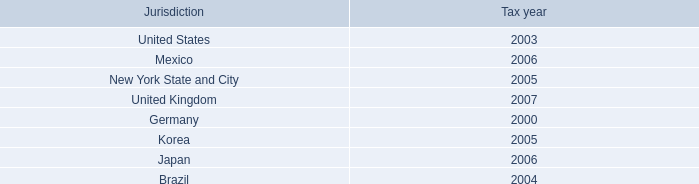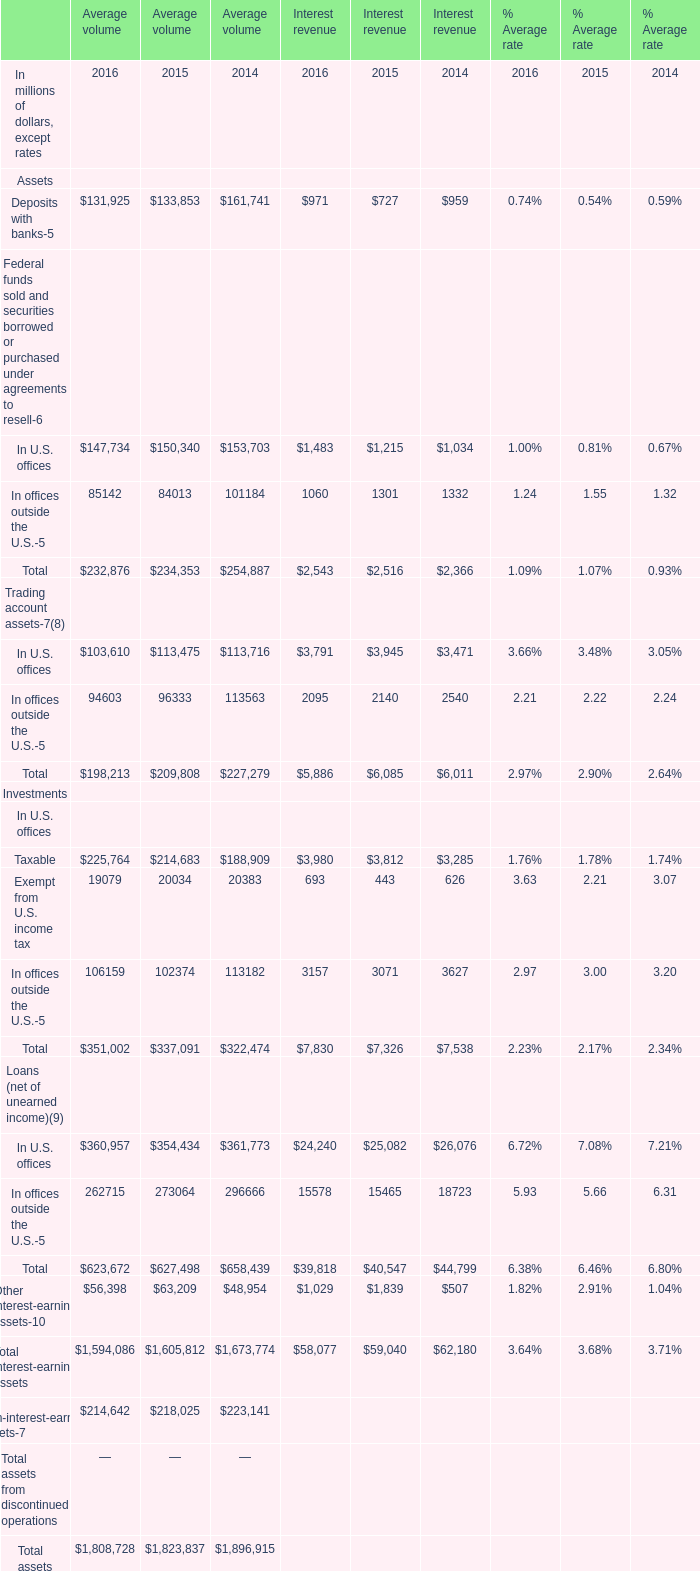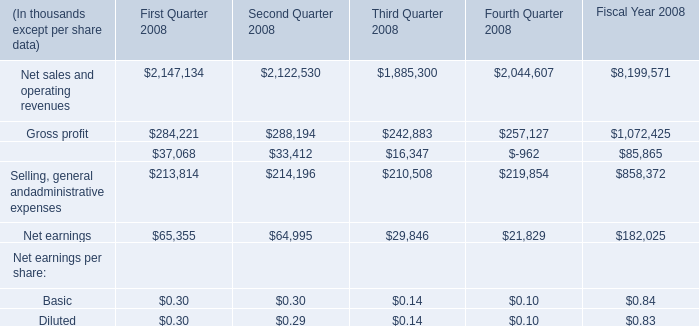What is the average amount of Net earnings of First Quarter 2008, and Taxable In U.S. offices of Average volume 2014 ? 
Computations: ((65355.0 + 188909.0) / 2)
Answer: 127132.0. 